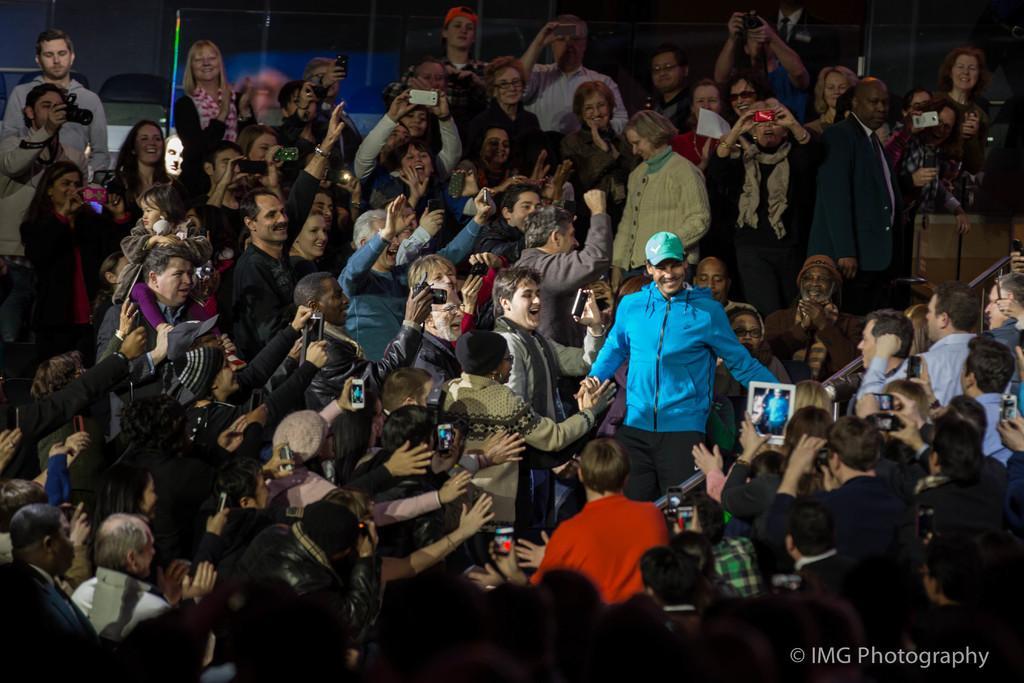Could you give a brief overview of what you see in this image? In this picture I can see group of people standing and holding the cameras and mobiles, there are iron rods, chairs, and there is a watermark on the image. 